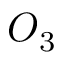Convert formula to latex. <formula><loc_0><loc_0><loc_500><loc_500>O _ { 3 }</formula> 